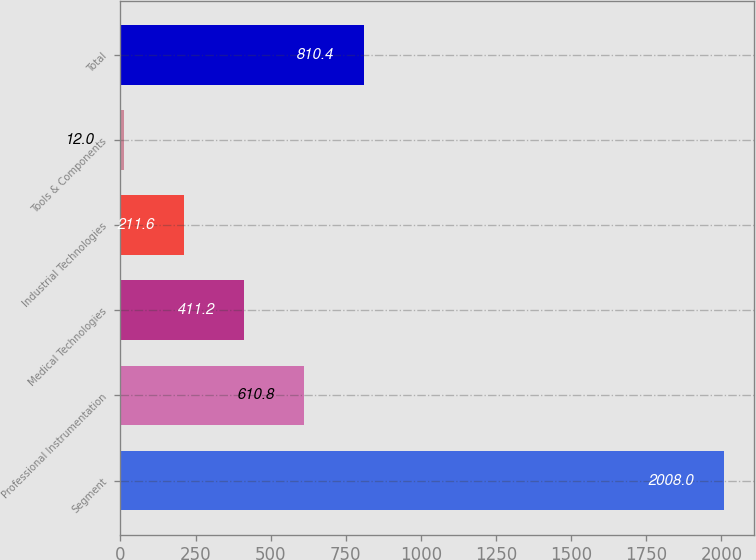Convert chart to OTSL. <chart><loc_0><loc_0><loc_500><loc_500><bar_chart><fcel>Segment<fcel>Professional Instrumentation<fcel>Medical Technologies<fcel>Industrial Technologies<fcel>Tools & Components<fcel>Total<nl><fcel>2008<fcel>610.8<fcel>411.2<fcel>211.6<fcel>12<fcel>810.4<nl></chart> 